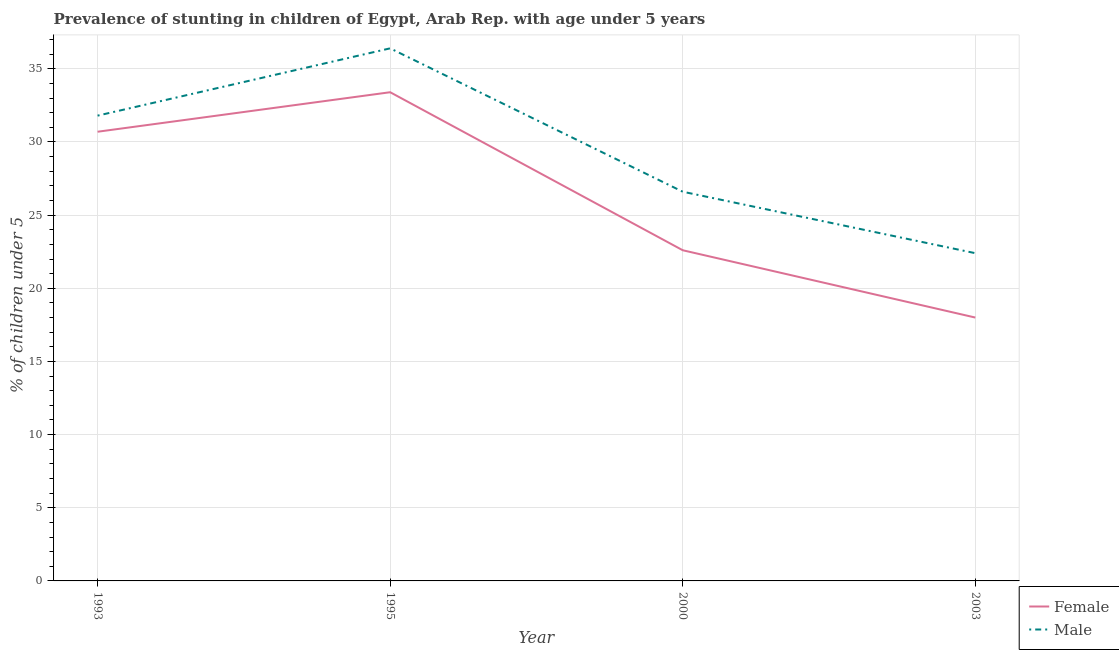Is the number of lines equal to the number of legend labels?
Your answer should be compact. Yes. What is the percentage of stunted female children in 2000?
Make the answer very short. 22.6. Across all years, what is the maximum percentage of stunted female children?
Your answer should be compact. 33.4. Across all years, what is the minimum percentage of stunted female children?
Offer a very short reply. 18. In which year was the percentage of stunted female children maximum?
Offer a very short reply. 1995. What is the total percentage of stunted female children in the graph?
Give a very brief answer. 104.7. What is the difference between the percentage of stunted male children in 1995 and that in 2003?
Offer a terse response. 14. What is the difference between the percentage of stunted female children in 1993 and the percentage of stunted male children in 2000?
Your answer should be very brief. 4.1. What is the average percentage of stunted male children per year?
Your answer should be compact. 29.3. In the year 1993, what is the difference between the percentage of stunted male children and percentage of stunted female children?
Offer a terse response. 1.1. In how many years, is the percentage of stunted female children greater than 23 %?
Give a very brief answer. 2. What is the ratio of the percentage of stunted female children in 1993 to that in 2000?
Keep it short and to the point. 1.36. Is the percentage of stunted male children in 1993 less than that in 1995?
Keep it short and to the point. Yes. What is the difference between the highest and the second highest percentage of stunted male children?
Offer a terse response. 4.6. What is the difference between the highest and the lowest percentage of stunted female children?
Your response must be concise. 15.4. Does the percentage of stunted male children monotonically increase over the years?
Ensure brevity in your answer.  No. Is the percentage of stunted female children strictly greater than the percentage of stunted male children over the years?
Provide a short and direct response. No. How many lines are there?
Provide a short and direct response. 2. Are the values on the major ticks of Y-axis written in scientific E-notation?
Make the answer very short. No. Does the graph contain grids?
Offer a terse response. Yes. How many legend labels are there?
Offer a terse response. 2. What is the title of the graph?
Offer a terse response. Prevalence of stunting in children of Egypt, Arab Rep. with age under 5 years. Does "Crop" appear as one of the legend labels in the graph?
Keep it short and to the point. No. What is the label or title of the X-axis?
Provide a succinct answer. Year. What is the label or title of the Y-axis?
Offer a terse response.  % of children under 5. What is the  % of children under 5 in Female in 1993?
Provide a succinct answer. 30.7. What is the  % of children under 5 of Male in 1993?
Keep it short and to the point. 31.8. What is the  % of children under 5 of Female in 1995?
Keep it short and to the point. 33.4. What is the  % of children under 5 of Male in 1995?
Offer a very short reply. 36.4. What is the  % of children under 5 of Female in 2000?
Make the answer very short. 22.6. What is the  % of children under 5 in Male in 2000?
Ensure brevity in your answer.  26.6. What is the  % of children under 5 in Male in 2003?
Give a very brief answer. 22.4. Across all years, what is the maximum  % of children under 5 in Female?
Make the answer very short. 33.4. Across all years, what is the maximum  % of children under 5 of Male?
Ensure brevity in your answer.  36.4. Across all years, what is the minimum  % of children under 5 in Male?
Your response must be concise. 22.4. What is the total  % of children under 5 of Female in the graph?
Provide a succinct answer. 104.7. What is the total  % of children under 5 of Male in the graph?
Offer a terse response. 117.2. What is the difference between the  % of children under 5 in Male in 1993 and that in 1995?
Offer a terse response. -4.6. What is the difference between the  % of children under 5 of Male in 1993 and that in 2000?
Keep it short and to the point. 5.2. What is the difference between the  % of children under 5 in Female in 1995 and that in 2000?
Your answer should be compact. 10.8. What is the difference between the  % of children under 5 in Female in 1993 and the  % of children under 5 in Male in 2003?
Provide a short and direct response. 8.3. What is the difference between the  % of children under 5 of Female in 1995 and the  % of children under 5 of Male in 2003?
Provide a succinct answer. 11. What is the average  % of children under 5 of Female per year?
Keep it short and to the point. 26.18. What is the average  % of children under 5 of Male per year?
Give a very brief answer. 29.3. In the year 2000, what is the difference between the  % of children under 5 in Female and  % of children under 5 in Male?
Your answer should be compact. -4. What is the ratio of the  % of children under 5 in Female in 1993 to that in 1995?
Offer a terse response. 0.92. What is the ratio of the  % of children under 5 in Male in 1993 to that in 1995?
Your answer should be compact. 0.87. What is the ratio of the  % of children under 5 in Female in 1993 to that in 2000?
Your answer should be compact. 1.36. What is the ratio of the  % of children under 5 in Male in 1993 to that in 2000?
Offer a very short reply. 1.2. What is the ratio of the  % of children under 5 of Female in 1993 to that in 2003?
Make the answer very short. 1.71. What is the ratio of the  % of children under 5 in Male in 1993 to that in 2003?
Provide a succinct answer. 1.42. What is the ratio of the  % of children under 5 in Female in 1995 to that in 2000?
Ensure brevity in your answer.  1.48. What is the ratio of the  % of children under 5 in Male in 1995 to that in 2000?
Offer a terse response. 1.37. What is the ratio of the  % of children under 5 of Female in 1995 to that in 2003?
Offer a terse response. 1.86. What is the ratio of the  % of children under 5 in Male in 1995 to that in 2003?
Offer a terse response. 1.62. What is the ratio of the  % of children under 5 in Female in 2000 to that in 2003?
Keep it short and to the point. 1.26. What is the ratio of the  % of children under 5 in Male in 2000 to that in 2003?
Offer a terse response. 1.19. What is the difference between the highest and the lowest  % of children under 5 in Female?
Your response must be concise. 15.4. 